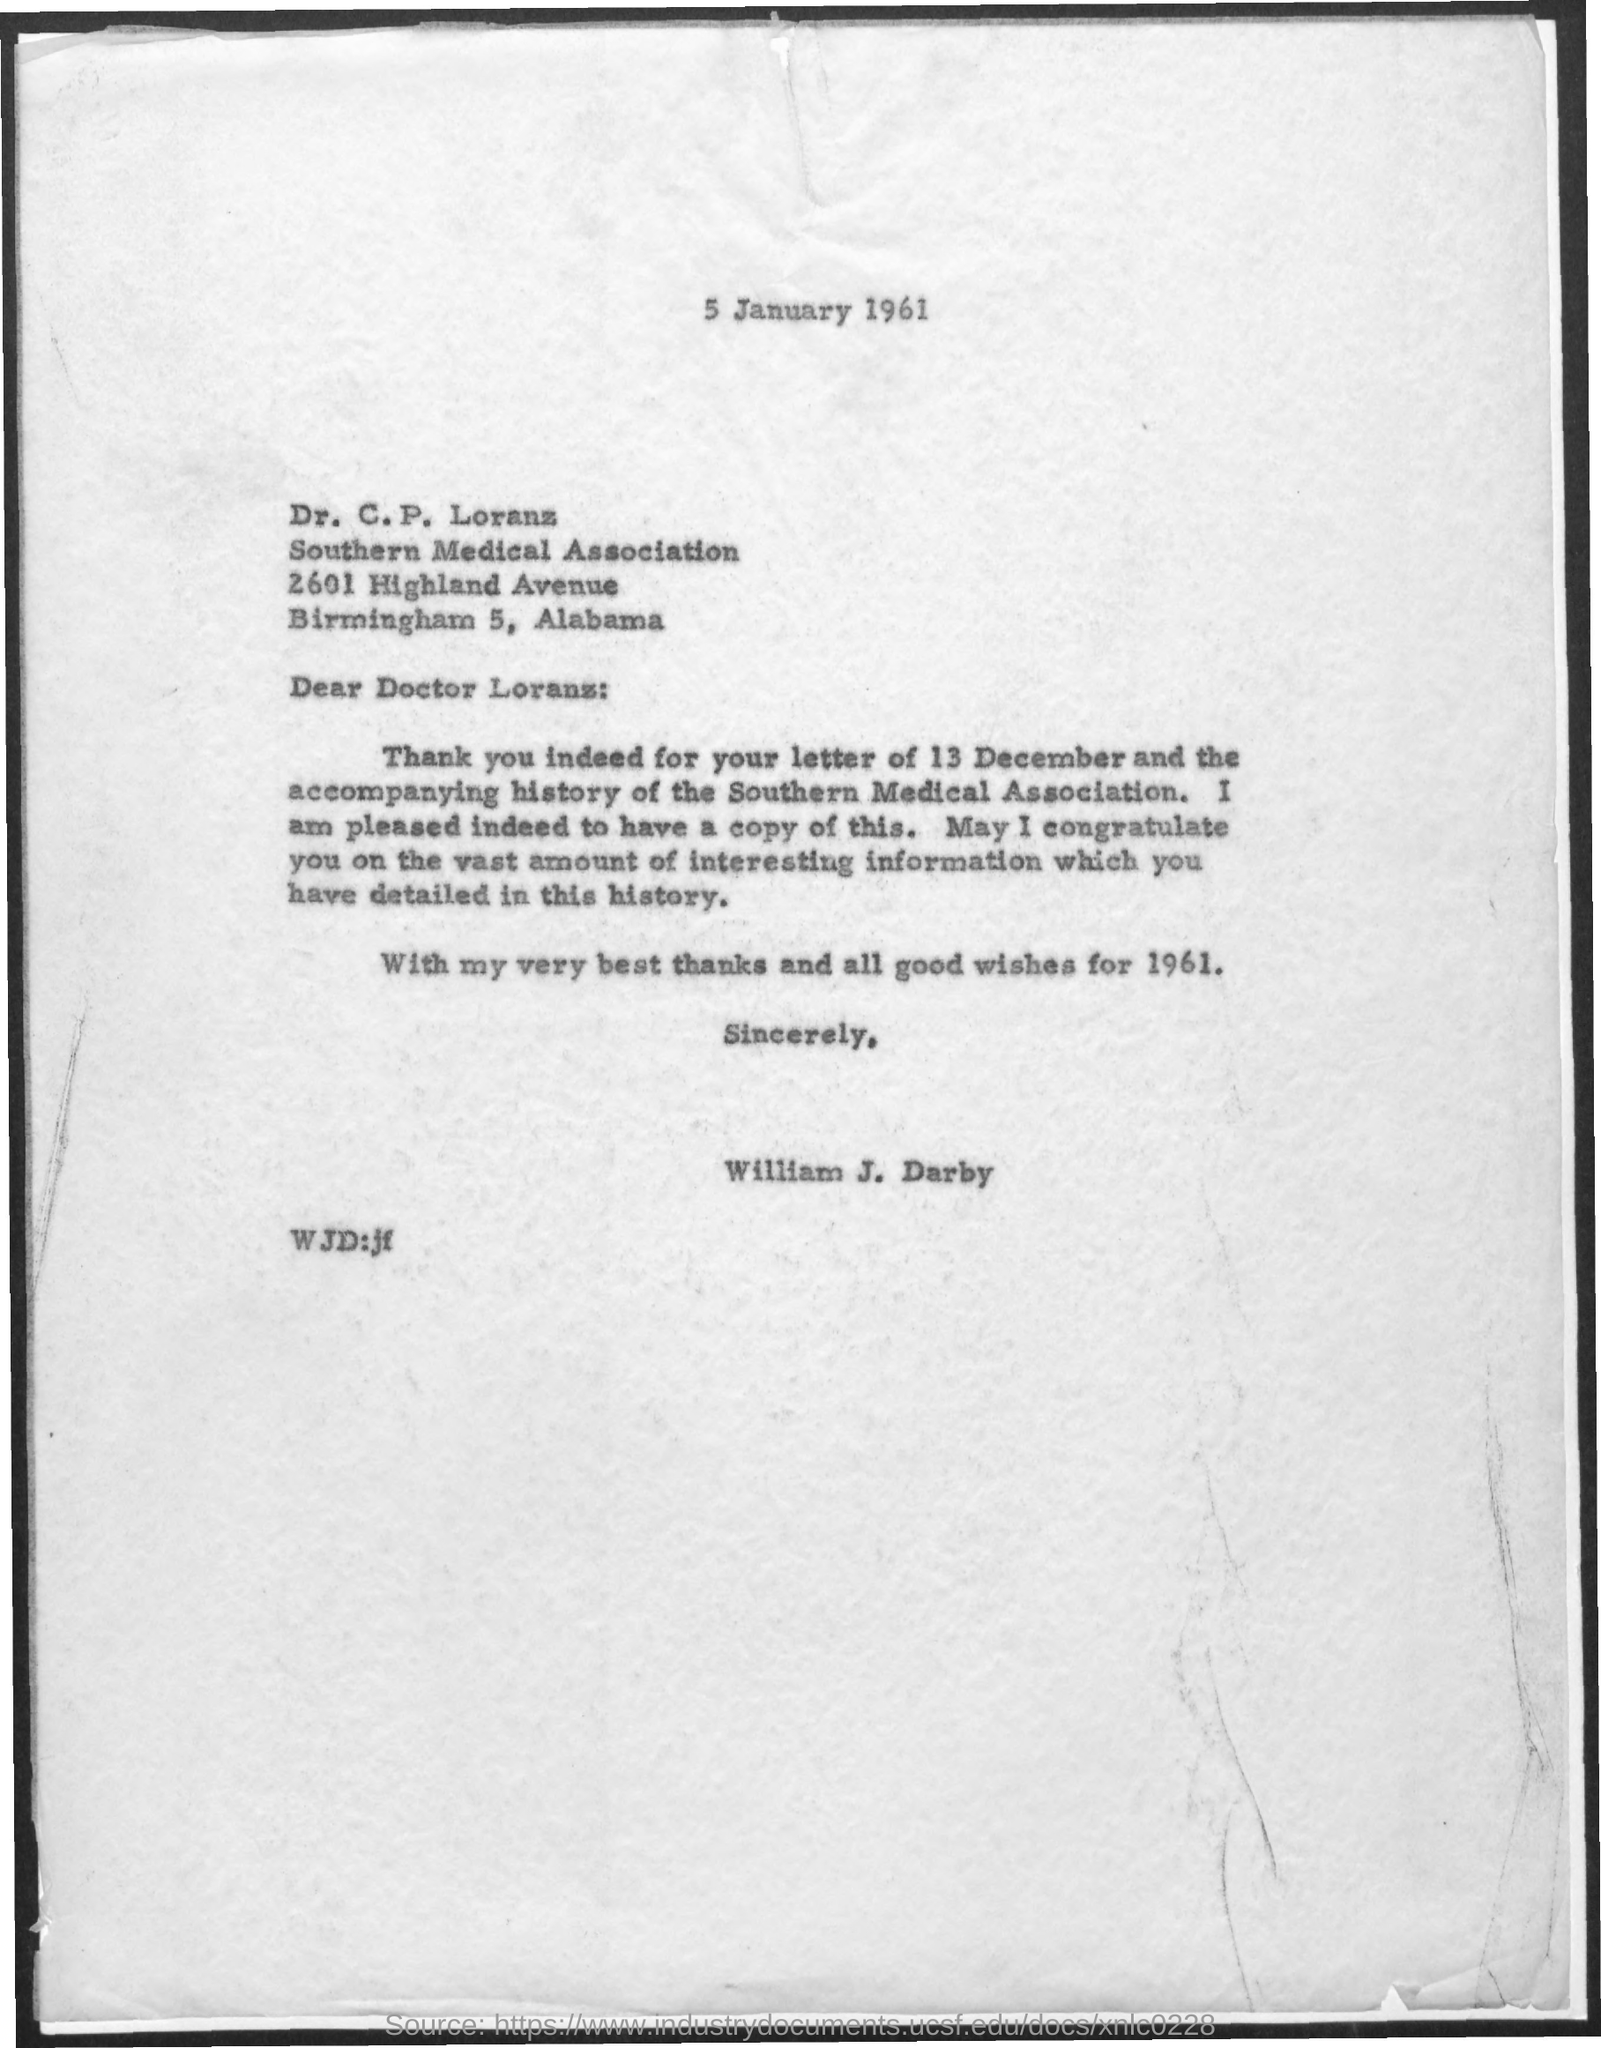Point out several critical features in this image. The letter was written by William J. Darby. The date at the top of the page is January 5, 1961. 